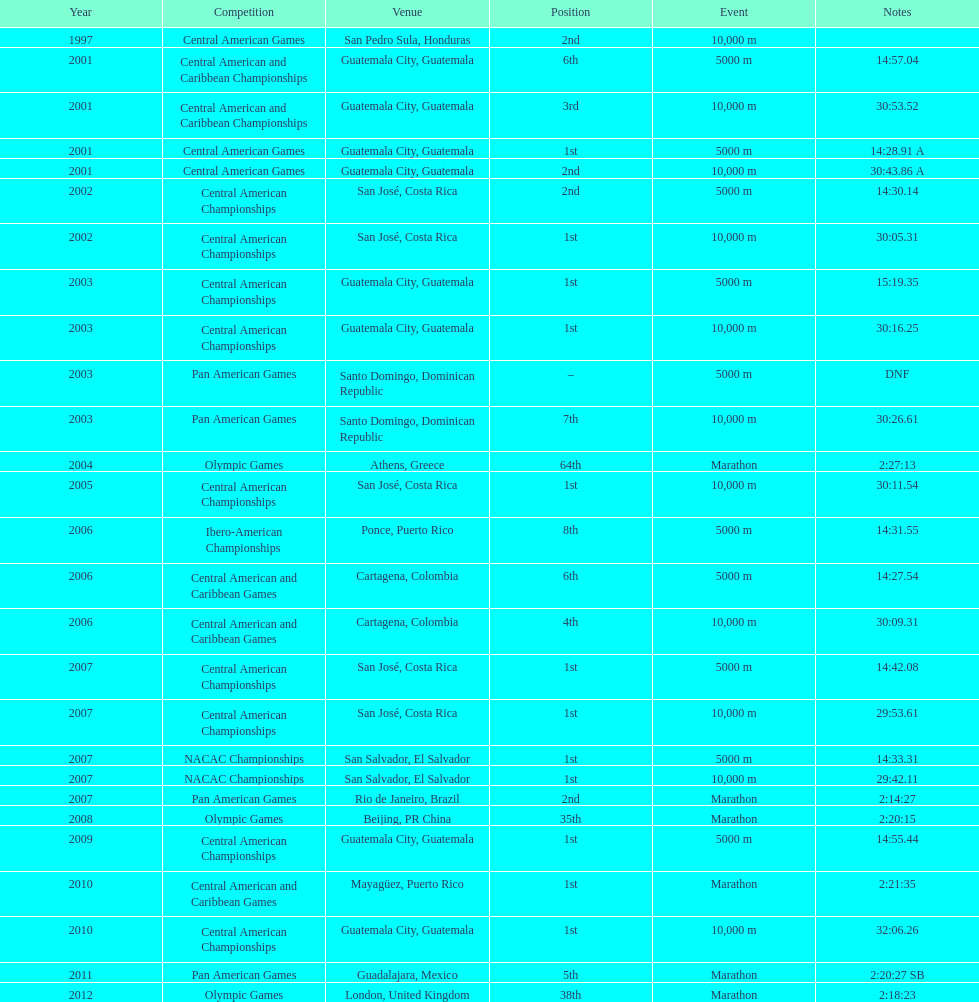In which most recent contest was a rank of "2nd" attained? Pan American Games. 